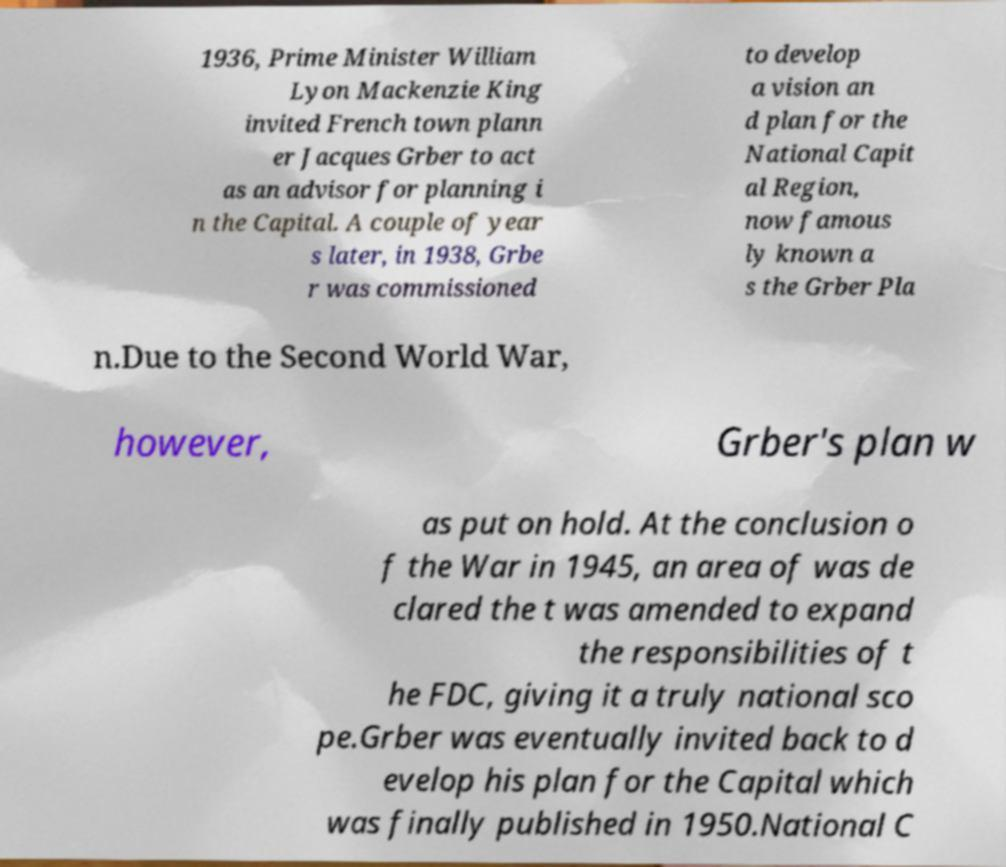Can you accurately transcribe the text from the provided image for me? 1936, Prime Minister William Lyon Mackenzie King invited French town plann er Jacques Grber to act as an advisor for planning i n the Capital. A couple of year s later, in 1938, Grbe r was commissioned to develop a vision an d plan for the National Capit al Region, now famous ly known a s the Grber Pla n.Due to the Second World War, however, Grber's plan w as put on hold. At the conclusion o f the War in 1945, an area of was de clared the t was amended to expand the responsibilities of t he FDC, giving it a truly national sco pe.Grber was eventually invited back to d evelop his plan for the Capital which was finally published in 1950.National C 